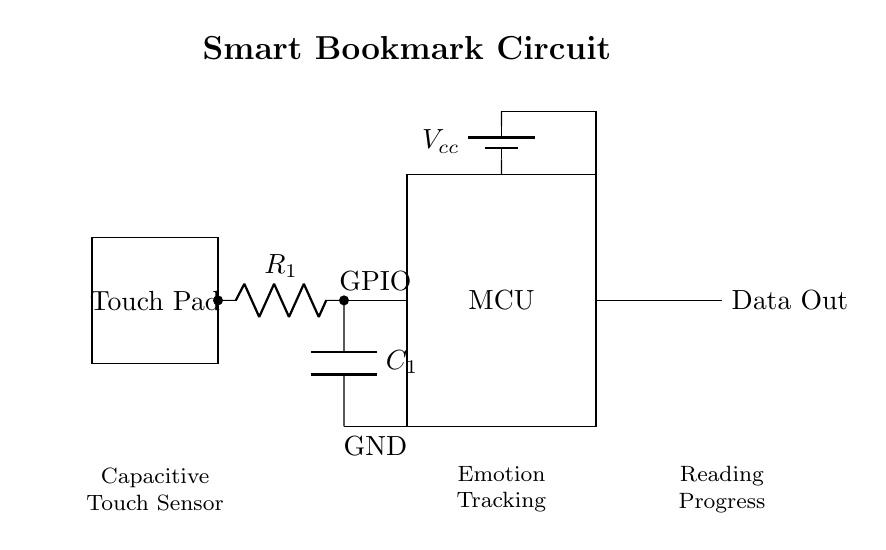What is the main function of the touch pad? The touch pad acts as an interface for user interaction, allowing the user to indicate their reading progress and emotional responses.
Answer: User interface What component measures the touch input? The touch pad is the component that measures touch input through capacitive sensing, detecting changes in capacitance when a finger is placed on it.
Answer: Touch pad What type of sensor is used in this circuit? The circuit employs a capacitive touch sensor which detects touch through capacitance changes rather than mechanical pressure.
Answer: Capacitive What is the voltage supply in the circuit? The circuit uses a battery to provide the voltage supply, indicated as V cc in the battery symbol, which typically is five volts in such devices.
Answer: Five volts How does the microcontroller process the touch data? The microcontroller receives input data from the touch pad through a GPIO pin and processes this data to interpret the user's actions for reading progress and emotions.
Answer: GPIO pin What follows the capacitor in the circuit? The circuit shows that the output data follows the microcontroller, indicating the flow of processed information from the microcontroller to external devices or systems.
Answer: Data Out What is the function of the resistor in this circuit? The resistor is used to limit the current flowing through the circuit, helping to stabilize the operation of the capacitive touch sensor and ensuring accurate readings.
Answer: Current limiting 